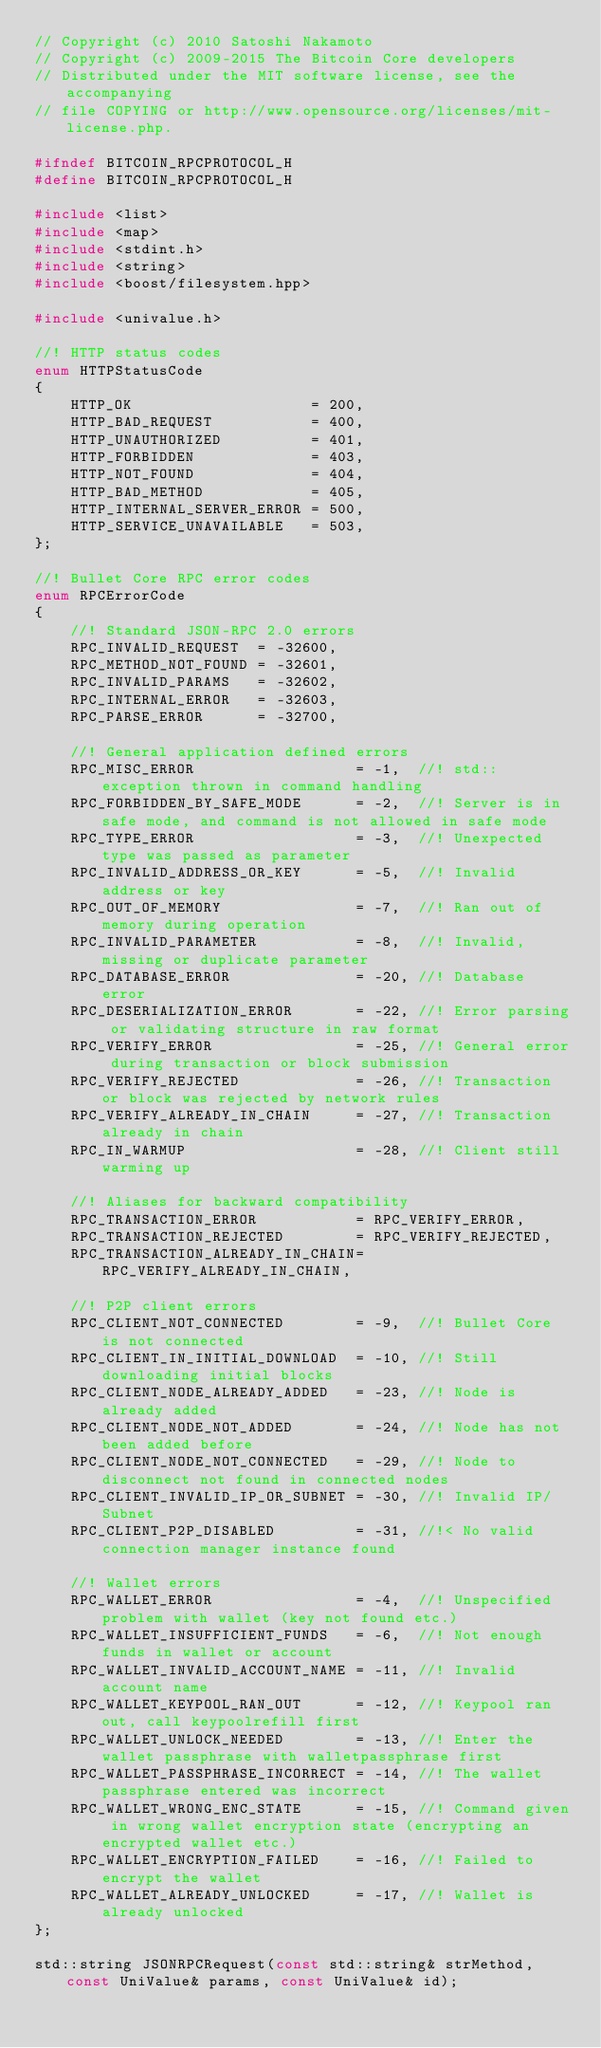Convert code to text. <code><loc_0><loc_0><loc_500><loc_500><_C_>// Copyright (c) 2010 Satoshi Nakamoto
// Copyright (c) 2009-2015 The Bitcoin Core developers
// Distributed under the MIT software license, see the accompanying
// file COPYING or http://www.opensource.org/licenses/mit-license.php.

#ifndef BITCOIN_RPCPROTOCOL_H
#define BITCOIN_RPCPROTOCOL_H

#include <list>
#include <map>
#include <stdint.h>
#include <string>
#include <boost/filesystem.hpp>

#include <univalue.h>

//! HTTP status codes
enum HTTPStatusCode
{
    HTTP_OK                    = 200,
    HTTP_BAD_REQUEST           = 400,
    HTTP_UNAUTHORIZED          = 401,
    HTTP_FORBIDDEN             = 403,
    HTTP_NOT_FOUND             = 404,
    HTTP_BAD_METHOD            = 405,
    HTTP_INTERNAL_SERVER_ERROR = 500,
    HTTP_SERVICE_UNAVAILABLE   = 503,
};

//! Bullet Core RPC error codes
enum RPCErrorCode
{
    //! Standard JSON-RPC 2.0 errors
    RPC_INVALID_REQUEST  = -32600,
    RPC_METHOD_NOT_FOUND = -32601,
    RPC_INVALID_PARAMS   = -32602,
    RPC_INTERNAL_ERROR   = -32603,
    RPC_PARSE_ERROR      = -32700,

    //! General application defined errors
    RPC_MISC_ERROR                  = -1,  //! std::exception thrown in command handling
    RPC_FORBIDDEN_BY_SAFE_MODE      = -2,  //! Server is in safe mode, and command is not allowed in safe mode
    RPC_TYPE_ERROR                  = -3,  //! Unexpected type was passed as parameter
    RPC_INVALID_ADDRESS_OR_KEY      = -5,  //! Invalid address or key
    RPC_OUT_OF_MEMORY               = -7,  //! Ran out of memory during operation
    RPC_INVALID_PARAMETER           = -8,  //! Invalid, missing or duplicate parameter
    RPC_DATABASE_ERROR              = -20, //! Database error
    RPC_DESERIALIZATION_ERROR       = -22, //! Error parsing or validating structure in raw format
    RPC_VERIFY_ERROR                = -25, //! General error during transaction or block submission
    RPC_VERIFY_REJECTED             = -26, //! Transaction or block was rejected by network rules
    RPC_VERIFY_ALREADY_IN_CHAIN     = -27, //! Transaction already in chain
    RPC_IN_WARMUP                   = -28, //! Client still warming up

    //! Aliases for backward compatibility
    RPC_TRANSACTION_ERROR           = RPC_VERIFY_ERROR,
    RPC_TRANSACTION_REJECTED        = RPC_VERIFY_REJECTED,
    RPC_TRANSACTION_ALREADY_IN_CHAIN= RPC_VERIFY_ALREADY_IN_CHAIN,

    //! P2P client errors
    RPC_CLIENT_NOT_CONNECTED        = -9,  //! Bullet Core is not connected
    RPC_CLIENT_IN_INITIAL_DOWNLOAD  = -10, //! Still downloading initial blocks
    RPC_CLIENT_NODE_ALREADY_ADDED   = -23, //! Node is already added
    RPC_CLIENT_NODE_NOT_ADDED       = -24, //! Node has not been added before
    RPC_CLIENT_NODE_NOT_CONNECTED   = -29, //! Node to disconnect not found in connected nodes
    RPC_CLIENT_INVALID_IP_OR_SUBNET = -30, //! Invalid IP/Subnet
    RPC_CLIENT_P2P_DISABLED         = -31, //!< No valid connection manager instance found

    //! Wallet errors
    RPC_WALLET_ERROR                = -4,  //! Unspecified problem with wallet (key not found etc.)
    RPC_WALLET_INSUFFICIENT_FUNDS   = -6,  //! Not enough funds in wallet or account
    RPC_WALLET_INVALID_ACCOUNT_NAME = -11, //! Invalid account name
    RPC_WALLET_KEYPOOL_RAN_OUT      = -12, //! Keypool ran out, call keypoolrefill first
    RPC_WALLET_UNLOCK_NEEDED        = -13, //! Enter the wallet passphrase with walletpassphrase first
    RPC_WALLET_PASSPHRASE_INCORRECT = -14, //! The wallet passphrase entered was incorrect
    RPC_WALLET_WRONG_ENC_STATE      = -15, //! Command given in wrong wallet encryption state (encrypting an encrypted wallet etc.)
    RPC_WALLET_ENCRYPTION_FAILED    = -16, //! Failed to encrypt the wallet
    RPC_WALLET_ALREADY_UNLOCKED     = -17, //! Wallet is already unlocked
};

std::string JSONRPCRequest(const std::string& strMethod, const UniValue& params, const UniValue& id);</code> 